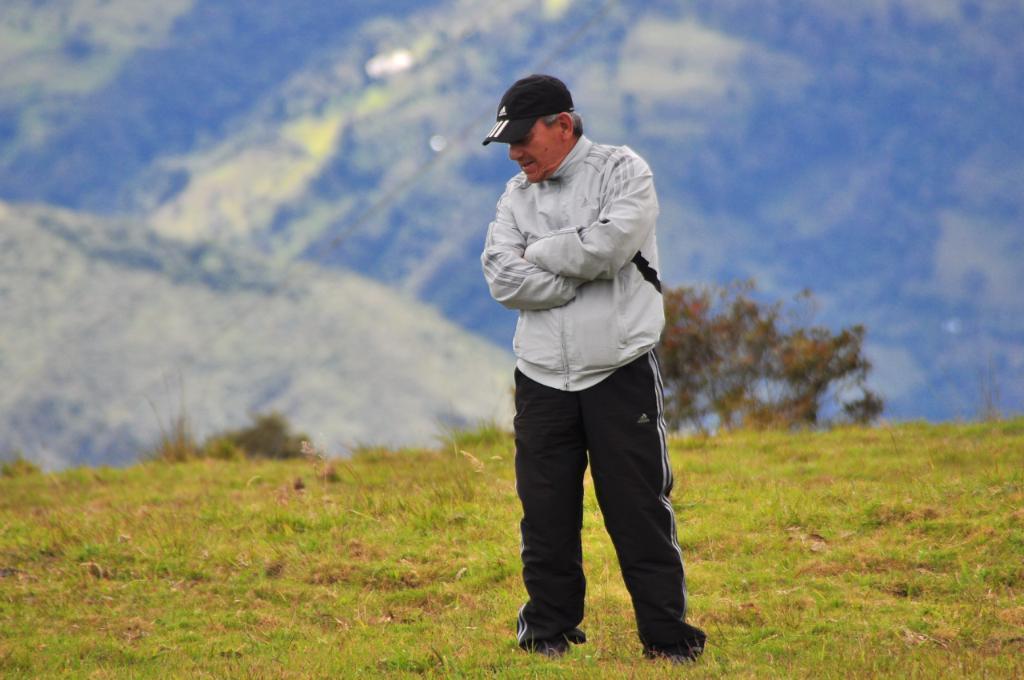Can you describe this image briefly? In this image we can see a person standing. There is grass and plants. In the background we can see hills and sky.  